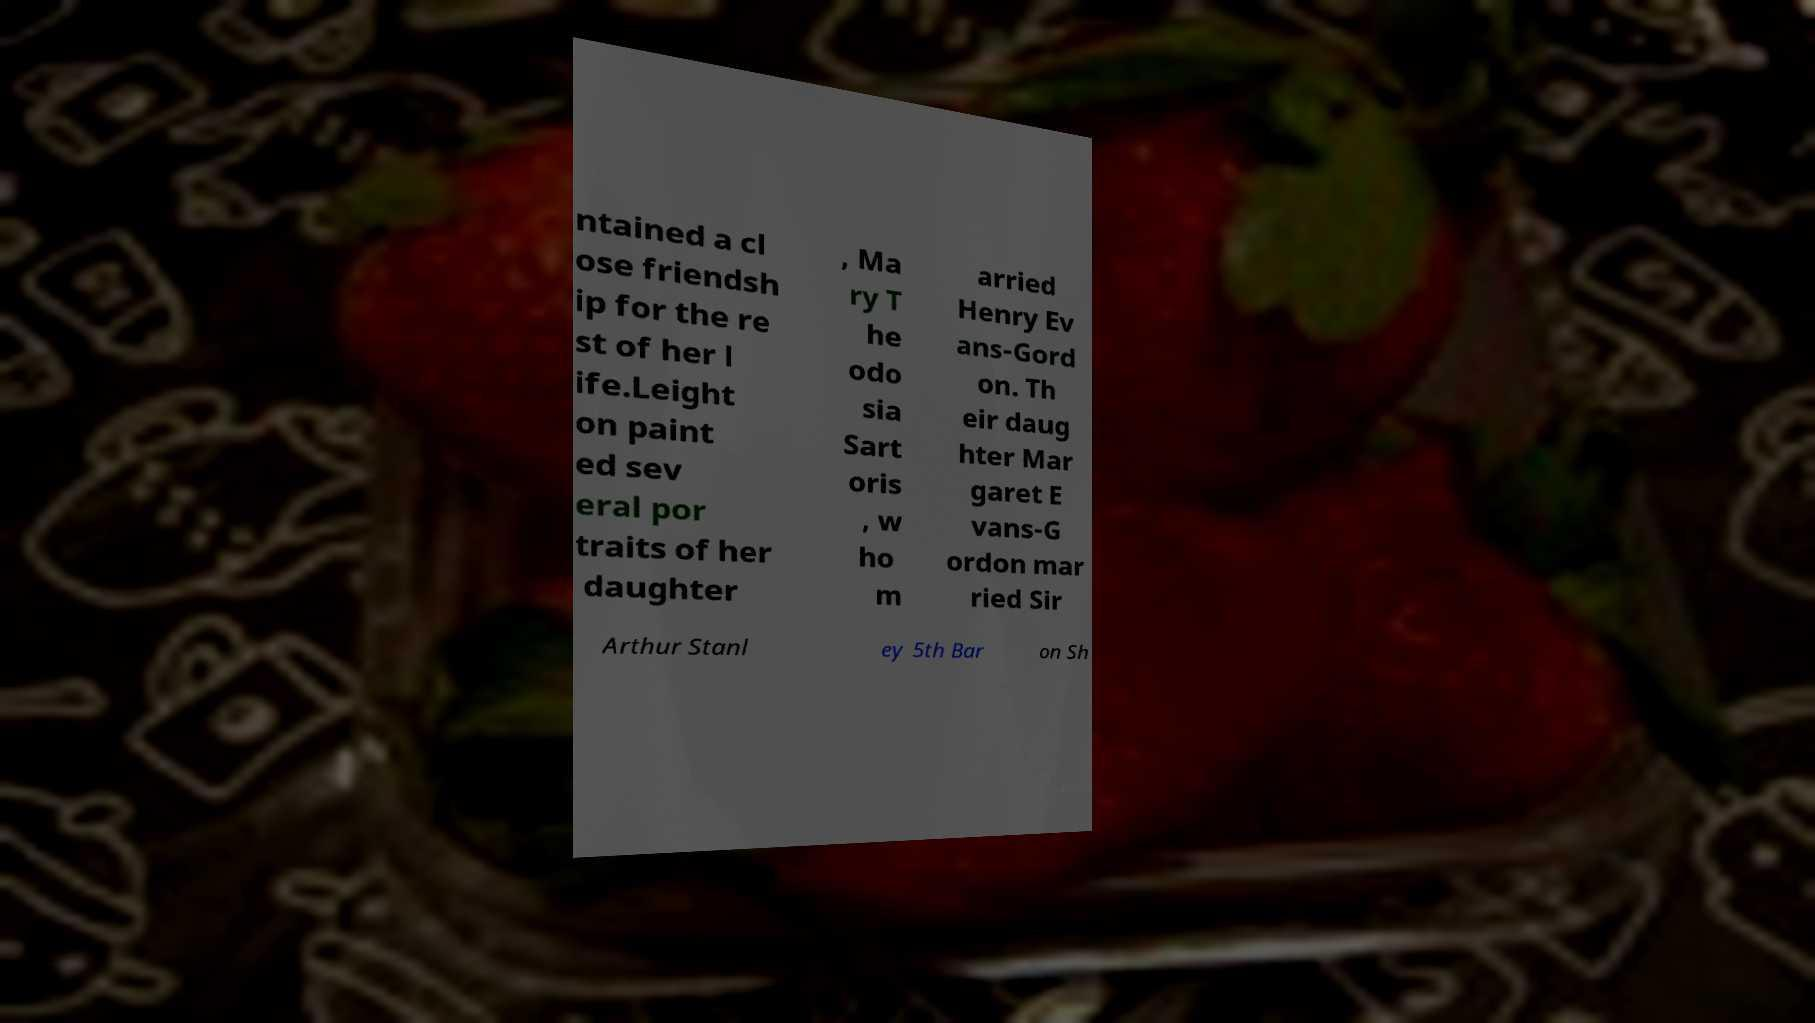Can you read and provide the text displayed in the image?This photo seems to have some interesting text. Can you extract and type it out for me? ntained a cl ose friendsh ip for the re st of her l ife.Leight on paint ed sev eral por traits of her daughter , Ma ry T he odo sia Sart oris , w ho m arried Henry Ev ans-Gord on. Th eir daug hter Mar garet E vans-G ordon mar ried Sir Arthur Stanl ey 5th Bar on Sh 